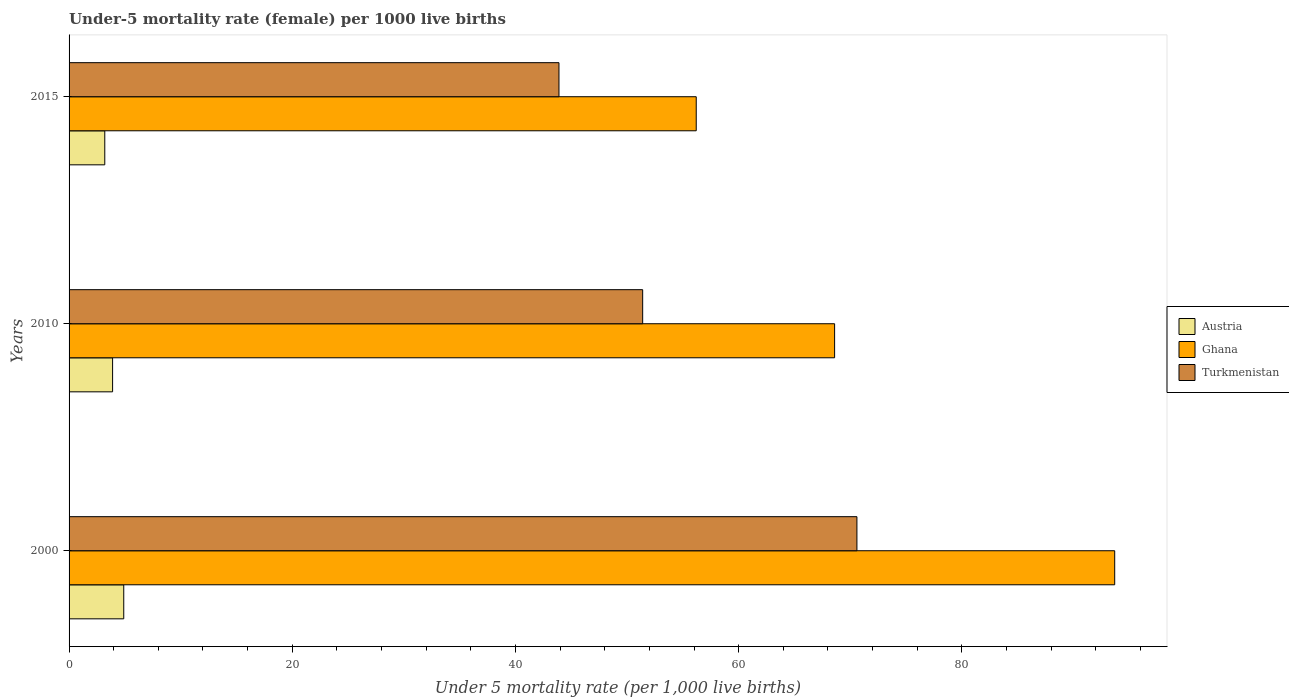Are the number of bars per tick equal to the number of legend labels?
Your answer should be very brief. Yes. How many bars are there on the 1st tick from the top?
Ensure brevity in your answer.  3. How many bars are there on the 2nd tick from the bottom?
Your answer should be very brief. 3. What is the label of the 2nd group of bars from the top?
Offer a terse response. 2010. What is the under-five mortality rate in Ghana in 2015?
Offer a terse response. 56.2. Across all years, what is the maximum under-five mortality rate in Ghana?
Offer a terse response. 93.7. Across all years, what is the minimum under-five mortality rate in Ghana?
Provide a succinct answer. 56.2. In which year was the under-five mortality rate in Ghana maximum?
Provide a short and direct response. 2000. In which year was the under-five mortality rate in Austria minimum?
Your answer should be compact. 2015. What is the difference between the under-five mortality rate in Turkmenistan in 2000 and that in 2015?
Make the answer very short. 26.7. What is the difference between the under-five mortality rate in Turkmenistan in 2010 and the under-five mortality rate in Ghana in 2015?
Offer a very short reply. -4.8. What is the average under-five mortality rate in Ghana per year?
Offer a very short reply. 72.83. In the year 2010, what is the difference between the under-five mortality rate in Ghana and under-five mortality rate in Austria?
Keep it short and to the point. 64.7. In how many years, is the under-five mortality rate in Austria greater than 32 ?
Make the answer very short. 0. What is the ratio of the under-five mortality rate in Turkmenistan in 2010 to that in 2015?
Offer a terse response. 1.17. Is the under-five mortality rate in Austria in 2000 less than that in 2015?
Make the answer very short. No. What is the difference between the highest and the second highest under-five mortality rate in Austria?
Your answer should be compact. 1. What is the difference between the highest and the lowest under-five mortality rate in Turkmenistan?
Provide a succinct answer. 26.7. What does the 3rd bar from the bottom in 2000 represents?
Provide a short and direct response. Turkmenistan. Is it the case that in every year, the sum of the under-five mortality rate in Ghana and under-five mortality rate in Turkmenistan is greater than the under-five mortality rate in Austria?
Offer a very short reply. Yes. What is the difference between two consecutive major ticks on the X-axis?
Your answer should be compact. 20. Are the values on the major ticks of X-axis written in scientific E-notation?
Your response must be concise. No. Does the graph contain grids?
Make the answer very short. No. How are the legend labels stacked?
Keep it short and to the point. Vertical. What is the title of the graph?
Your answer should be compact. Under-5 mortality rate (female) per 1000 live births. What is the label or title of the X-axis?
Keep it short and to the point. Under 5 mortality rate (per 1,0 live births). What is the Under 5 mortality rate (per 1,000 live births) in Austria in 2000?
Provide a short and direct response. 4.9. What is the Under 5 mortality rate (per 1,000 live births) of Ghana in 2000?
Offer a terse response. 93.7. What is the Under 5 mortality rate (per 1,000 live births) of Turkmenistan in 2000?
Your response must be concise. 70.6. What is the Under 5 mortality rate (per 1,000 live births) in Ghana in 2010?
Give a very brief answer. 68.6. What is the Under 5 mortality rate (per 1,000 live births) in Turkmenistan in 2010?
Make the answer very short. 51.4. What is the Under 5 mortality rate (per 1,000 live births) in Austria in 2015?
Offer a very short reply. 3.2. What is the Under 5 mortality rate (per 1,000 live births) of Ghana in 2015?
Offer a very short reply. 56.2. What is the Under 5 mortality rate (per 1,000 live births) of Turkmenistan in 2015?
Your answer should be compact. 43.9. Across all years, what is the maximum Under 5 mortality rate (per 1,000 live births) of Ghana?
Make the answer very short. 93.7. Across all years, what is the maximum Under 5 mortality rate (per 1,000 live births) of Turkmenistan?
Keep it short and to the point. 70.6. Across all years, what is the minimum Under 5 mortality rate (per 1,000 live births) of Austria?
Your answer should be very brief. 3.2. Across all years, what is the minimum Under 5 mortality rate (per 1,000 live births) in Ghana?
Offer a terse response. 56.2. Across all years, what is the minimum Under 5 mortality rate (per 1,000 live births) in Turkmenistan?
Your answer should be very brief. 43.9. What is the total Under 5 mortality rate (per 1,000 live births) of Austria in the graph?
Provide a succinct answer. 12. What is the total Under 5 mortality rate (per 1,000 live births) in Ghana in the graph?
Give a very brief answer. 218.5. What is the total Under 5 mortality rate (per 1,000 live births) of Turkmenistan in the graph?
Provide a short and direct response. 165.9. What is the difference between the Under 5 mortality rate (per 1,000 live births) of Austria in 2000 and that in 2010?
Ensure brevity in your answer.  1. What is the difference between the Under 5 mortality rate (per 1,000 live births) in Ghana in 2000 and that in 2010?
Make the answer very short. 25.1. What is the difference between the Under 5 mortality rate (per 1,000 live births) in Austria in 2000 and that in 2015?
Your answer should be compact. 1.7. What is the difference between the Under 5 mortality rate (per 1,000 live births) of Ghana in 2000 and that in 2015?
Provide a succinct answer. 37.5. What is the difference between the Under 5 mortality rate (per 1,000 live births) in Turkmenistan in 2000 and that in 2015?
Ensure brevity in your answer.  26.7. What is the difference between the Under 5 mortality rate (per 1,000 live births) in Austria in 2010 and that in 2015?
Your answer should be very brief. 0.7. What is the difference between the Under 5 mortality rate (per 1,000 live births) in Austria in 2000 and the Under 5 mortality rate (per 1,000 live births) in Ghana in 2010?
Your answer should be compact. -63.7. What is the difference between the Under 5 mortality rate (per 1,000 live births) of Austria in 2000 and the Under 5 mortality rate (per 1,000 live births) of Turkmenistan in 2010?
Offer a very short reply. -46.5. What is the difference between the Under 5 mortality rate (per 1,000 live births) in Ghana in 2000 and the Under 5 mortality rate (per 1,000 live births) in Turkmenistan in 2010?
Provide a succinct answer. 42.3. What is the difference between the Under 5 mortality rate (per 1,000 live births) in Austria in 2000 and the Under 5 mortality rate (per 1,000 live births) in Ghana in 2015?
Your answer should be compact. -51.3. What is the difference between the Under 5 mortality rate (per 1,000 live births) in Austria in 2000 and the Under 5 mortality rate (per 1,000 live births) in Turkmenistan in 2015?
Provide a short and direct response. -39. What is the difference between the Under 5 mortality rate (per 1,000 live births) of Ghana in 2000 and the Under 5 mortality rate (per 1,000 live births) of Turkmenistan in 2015?
Your answer should be compact. 49.8. What is the difference between the Under 5 mortality rate (per 1,000 live births) of Austria in 2010 and the Under 5 mortality rate (per 1,000 live births) of Ghana in 2015?
Ensure brevity in your answer.  -52.3. What is the difference between the Under 5 mortality rate (per 1,000 live births) of Ghana in 2010 and the Under 5 mortality rate (per 1,000 live births) of Turkmenistan in 2015?
Your answer should be compact. 24.7. What is the average Under 5 mortality rate (per 1,000 live births) in Ghana per year?
Make the answer very short. 72.83. What is the average Under 5 mortality rate (per 1,000 live births) of Turkmenistan per year?
Your answer should be compact. 55.3. In the year 2000, what is the difference between the Under 5 mortality rate (per 1,000 live births) in Austria and Under 5 mortality rate (per 1,000 live births) in Ghana?
Offer a very short reply. -88.8. In the year 2000, what is the difference between the Under 5 mortality rate (per 1,000 live births) in Austria and Under 5 mortality rate (per 1,000 live births) in Turkmenistan?
Keep it short and to the point. -65.7. In the year 2000, what is the difference between the Under 5 mortality rate (per 1,000 live births) in Ghana and Under 5 mortality rate (per 1,000 live births) in Turkmenistan?
Provide a short and direct response. 23.1. In the year 2010, what is the difference between the Under 5 mortality rate (per 1,000 live births) in Austria and Under 5 mortality rate (per 1,000 live births) in Ghana?
Keep it short and to the point. -64.7. In the year 2010, what is the difference between the Under 5 mortality rate (per 1,000 live births) in Austria and Under 5 mortality rate (per 1,000 live births) in Turkmenistan?
Ensure brevity in your answer.  -47.5. In the year 2010, what is the difference between the Under 5 mortality rate (per 1,000 live births) in Ghana and Under 5 mortality rate (per 1,000 live births) in Turkmenistan?
Offer a terse response. 17.2. In the year 2015, what is the difference between the Under 5 mortality rate (per 1,000 live births) of Austria and Under 5 mortality rate (per 1,000 live births) of Ghana?
Give a very brief answer. -53. In the year 2015, what is the difference between the Under 5 mortality rate (per 1,000 live births) of Austria and Under 5 mortality rate (per 1,000 live births) of Turkmenistan?
Ensure brevity in your answer.  -40.7. In the year 2015, what is the difference between the Under 5 mortality rate (per 1,000 live births) of Ghana and Under 5 mortality rate (per 1,000 live births) of Turkmenistan?
Provide a short and direct response. 12.3. What is the ratio of the Under 5 mortality rate (per 1,000 live births) of Austria in 2000 to that in 2010?
Offer a very short reply. 1.26. What is the ratio of the Under 5 mortality rate (per 1,000 live births) of Ghana in 2000 to that in 2010?
Make the answer very short. 1.37. What is the ratio of the Under 5 mortality rate (per 1,000 live births) of Turkmenistan in 2000 to that in 2010?
Offer a terse response. 1.37. What is the ratio of the Under 5 mortality rate (per 1,000 live births) in Austria in 2000 to that in 2015?
Give a very brief answer. 1.53. What is the ratio of the Under 5 mortality rate (per 1,000 live births) in Ghana in 2000 to that in 2015?
Ensure brevity in your answer.  1.67. What is the ratio of the Under 5 mortality rate (per 1,000 live births) of Turkmenistan in 2000 to that in 2015?
Your response must be concise. 1.61. What is the ratio of the Under 5 mortality rate (per 1,000 live births) in Austria in 2010 to that in 2015?
Ensure brevity in your answer.  1.22. What is the ratio of the Under 5 mortality rate (per 1,000 live births) in Ghana in 2010 to that in 2015?
Ensure brevity in your answer.  1.22. What is the ratio of the Under 5 mortality rate (per 1,000 live births) in Turkmenistan in 2010 to that in 2015?
Give a very brief answer. 1.17. What is the difference between the highest and the second highest Under 5 mortality rate (per 1,000 live births) of Ghana?
Keep it short and to the point. 25.1. What is the difference between the highest and the second highest Under 5 mortality rate (per 1,000 live births) of Turkmenistan?
Keep it short and to the point. 19.2. What is the difference between the highest and the lowest Under 5 mortality rate (per 1,000 live births) of Austria?
Keep it short and to the point. 1.7. What is the difference between the highest and the lowest Under 5 mortality rate (per 1,000 live births) in Ghana?
Provide a short and direct response. 37.5. What is the difference between the highest and the lowest Under 5 mortality rate (per 1,000 live births) in Turkmenistan?
Ensure brevity in your answer.  26.7. 